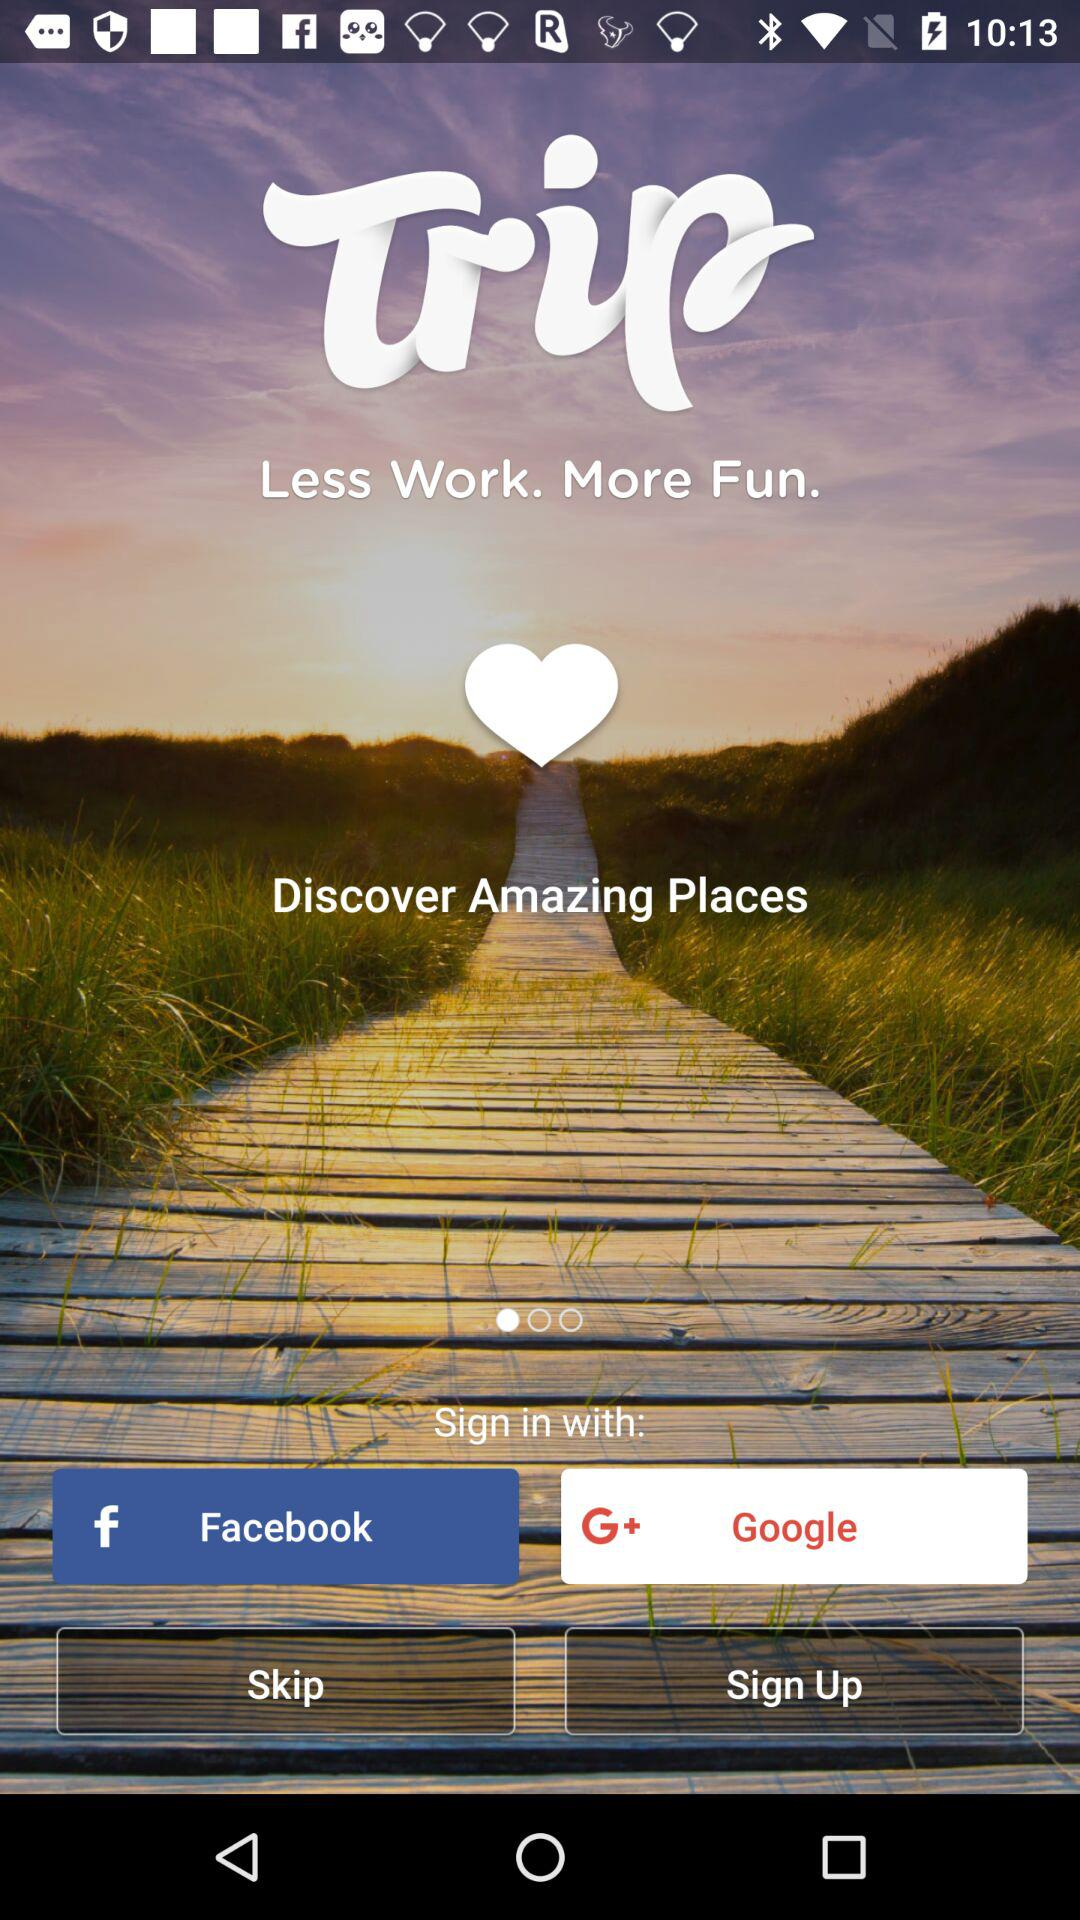What is the name of the application? The name of the application is "Trip". 